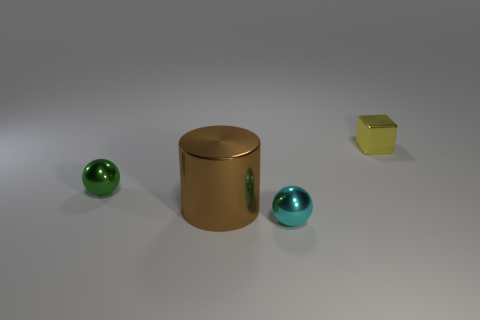Add 1 large cylinders. How many objects exist? 5 Subtract all cylinders. How many objects are left? 3 Subtract all red balls. Subtract all brown metallic cylinders. How many objects are left? 3 Add 2 cyan metal things. How many cyan metal things are left? 3 Add 2 small metallic things. How many small metallic things exist? 5 Subtract 0 brown blocks. How many objects are left? 4 